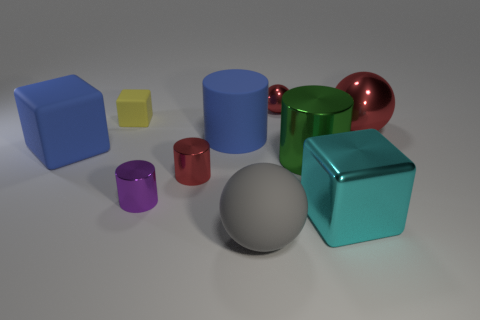Subtract 1 cylinders. How many cylinders are left? 3 Subtract all spheres. How many objects are left? 7 Subtract 0 cyan cylinders. How many objects are left? 10 Subtract all big purple matte spheres. Subtract all tiny things. How many objects are left? 6 Add 2 big blue cylinders. How many big blue cylinders are left? 3 Add 2 shiny spheres. How many shiny spheres exist? 4 